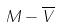<formula> <loc_0><loc_0><loc_500><loc_500>M - \overline { V }</formula> 